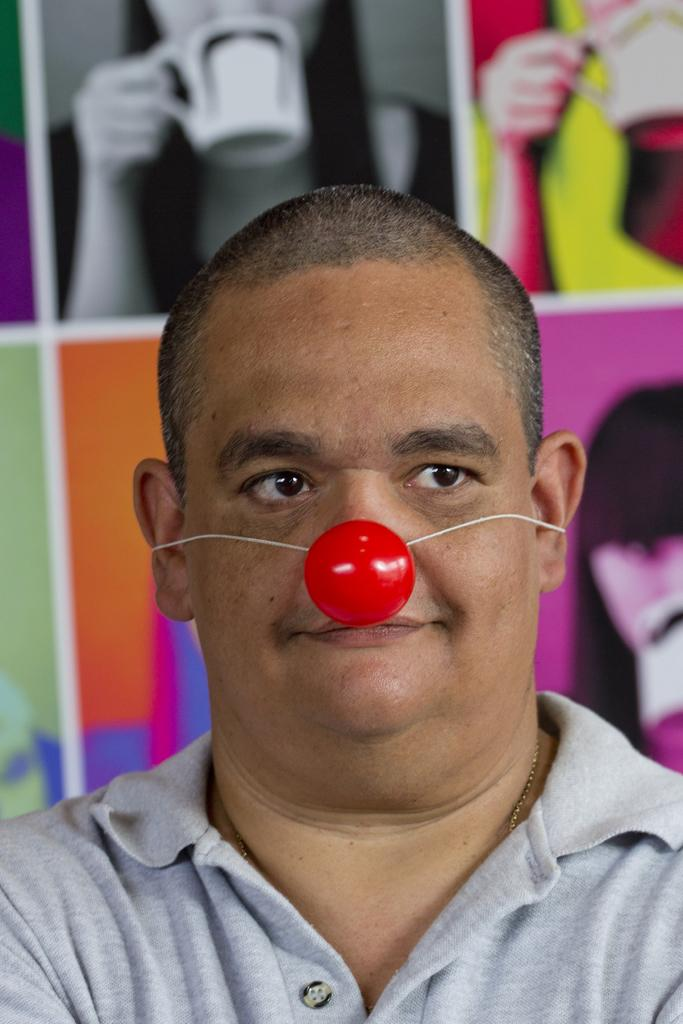Who or what is present in the image? There is a person in the image. What is the person wearing on their face? The person is wearing a red object on their face. Can you describe any other objects or features in the image? There is a colorful frame visible in the image. How many kittens are playing with the person's feet in the image? There are no kittens present in the image. Can you tell me if there is an airport visible in the background of the image? There is no mention of an airport or any background details in the provided facts. 